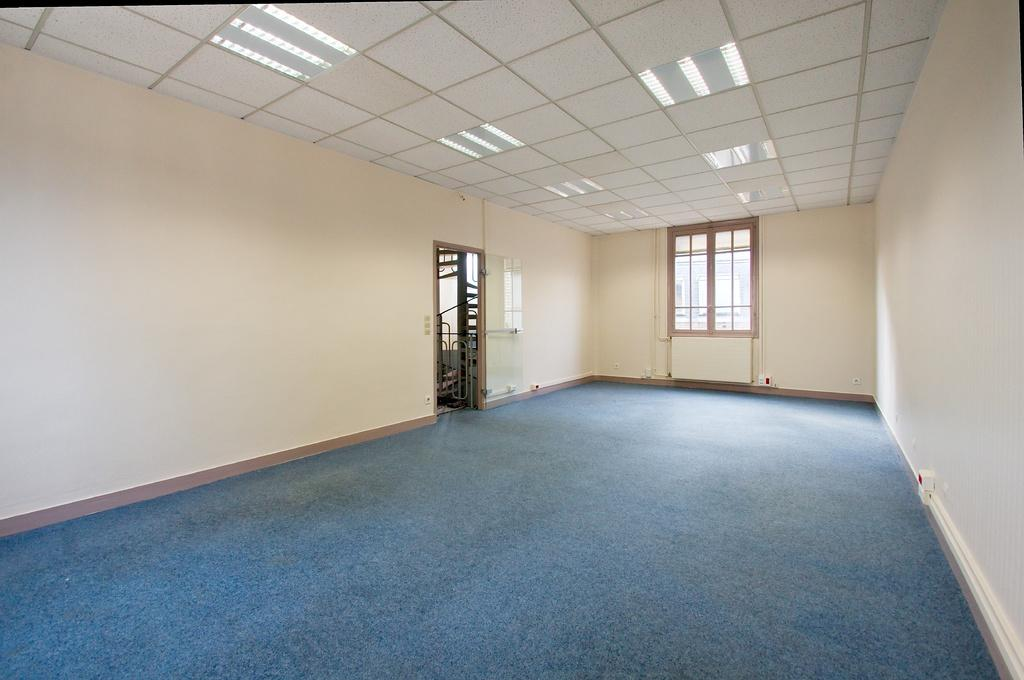What type of space is shown in the image? The image is an inside view of a room. What can be seen in the background of the room? There is a window in the background of the room. Where is the window located in the room? The window is on a wall. What other feature can be found in the room? There is a door in the room. What is present at the top of the room? There are lights at the top of the room. How many apples are being used as a source of pain in the image? There are no apples present in the image, and therefore no source of pain can be observed. 